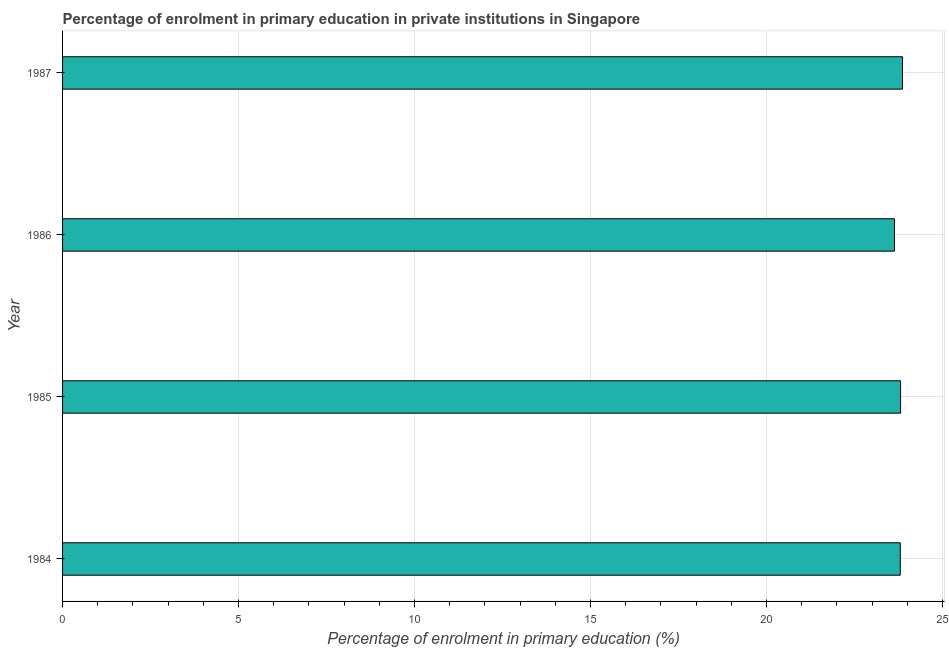Does the graph contain any zero values?
Your answer should be compact. No. Does the graph contain grids?
Offer a very short reply. Yes. What is the title of the graph?
Offer a terse response. Percentage of enrolment in primary education in private institutions in Singapore. What is the label or title of the X-axis?
Your response must be concise. Percentage of enrolment in primary education (%). What is the enrolment percentage in primary education in 1985?
Ensure brevity in your answer.  23.81. Across all years, what is the maximum enrolment percentage in primary education?
Offer a very short reply. 23.86. Across all years, what is the minimum enrolment percentage in primary education?
Ensure brevity in your answer.  23.64. In which year was the enrolment percentage in primary education minimum?
Offer a very short reply. 1986. What is the sum of the enrolment percentage in primary education?
Offer a very short reply. 95.11. What is the difference between the enrolment percentage in primary education in 1985 and 1986?
Give a very brief answer. 0.17. What is the average enrolment percentage in primary education per year?
Provide a succinct answer. 23.78. What is the median enrolment percentage in primary education?
Ensure brevity in your answer.  23.8. In how many years, is the enrolment percentage in primary education greater than 18 %?
Provide a short and direct response. 4. Do a majority of the years between 1984 and 1985 (inclusive) have enrolment percentage in primary education greater than 18 %?
Make the answer very short. Yes. Is the enrolment percentage in primary education in 1984 less than that in 1987?
Your response must be concise. Yes. Is the difference between the enrolment percentage in primary education in 1986 and 1987 greater than the difference between any two years?
Give a very brief answer. Yes. What is the difference between the highest and the second highest enrolment percentage in primary education?
Give a very brief answer. 0.05. What is the difference between the highest and the lowest enrolment percentage in primary education?
Your answer should be very brief. 0.23. How many bars are there?
Offer a terse response. 4. Are all the bars in the graph horizontal?
Keep it short and to the point. Yes. How many years are there in the graph?
Keep it short and to the point. 4. What is the difference between two consecutive major ticks on the X-axis?
Make the answer very short. 5. What is the Percentage of enrolment in primary education (%) in 1984?
Offer a very short reply. 23.8. What is the Percentage of enrolment in primary education (%) of 1985?
Ensure brevity in your answer.  23.81. What is the Percentage of enrolment in primary education (%) in 1986?
Your response must be concise. 23.64. What is the Percentage of enrolment in primary education (%) of 1987?
Provide a short and direct response. 23.86. What is the difference between the Percentage of enrolment in primary education (%) in 1984 and 1985?
Your response must be concise. -0.01. What is the difference between the Percentage of enrolment in primary education (%) in 1984 and 1986?
Your answer should be compact. 0.16. What is the difference between the Percentage of enrolment in primary education (%) in 1984 and 1987?
Provide a succinct answer. -0.06. What is the difference between the Percentage of enrolment in primary education (%) in 1985 and 1986?
Ensure brevity in your answer.  0.17. What is the difference between the Percentage of enrolment in primary education (%) in 1985 and 1987?
Keep it short and to the point. -0.05. What is the difference between the Percentage of enrolment in primary education (%) in 1986 and 1987?
Give a very brief answer. -0.23. What is the ratio of the Percentage of enrolment in primary education (%) in 1984 to that in 1985?
Your response must be concise. 1. What is the ratio of the Percentage of enrolment in primary education (%) in 1984 to that in 1986?
Your answer should be compact. 1.01. What is the ratio of the Percentage of enrolment in primary education (%) in 1985 to that in 1987?
Provide a succinct answer. 1. What is the ratio of the Percentage of enrolment in primary education (%) in 1986 to that in 1987?
Provide a short and direct response. 0.99. 